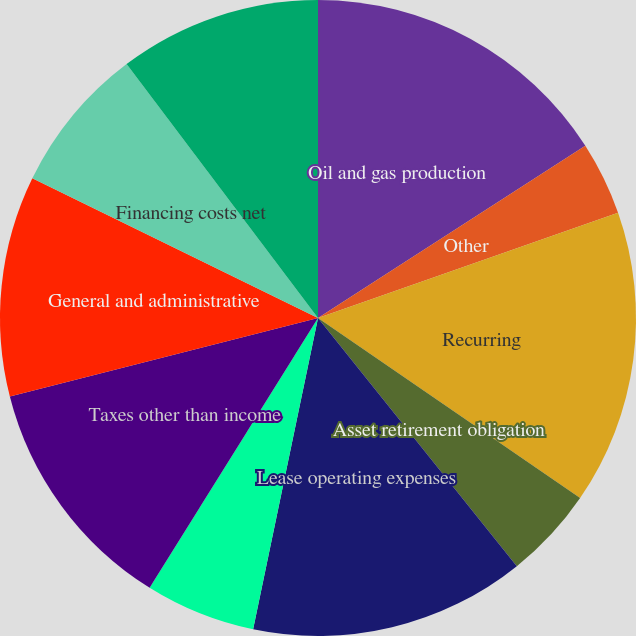<chart> <loc_0><loc_0><loc_500><loc_500><pie_chart><fcel>Oil and gas production<fcel>Other<fcel>Recurring<fcel>Asset retirement obligation<fcel>Lease operating expenses<fcel>Gathering and transportation<fcel>Taxes other than income<fcel>General and administrative<fcel>Financing costs net<fcel>INCOME BEFORE INCOME TAXES<nl><fcel>15.89%<fcel>3.74%<fcel>14.95%<fcel>4.67%<fcel>14.02%<fcel>5.61%<fcel>12.15%<fcel>11.21%<fcel>7.48%<fcel>10.28%<nl></chart> 